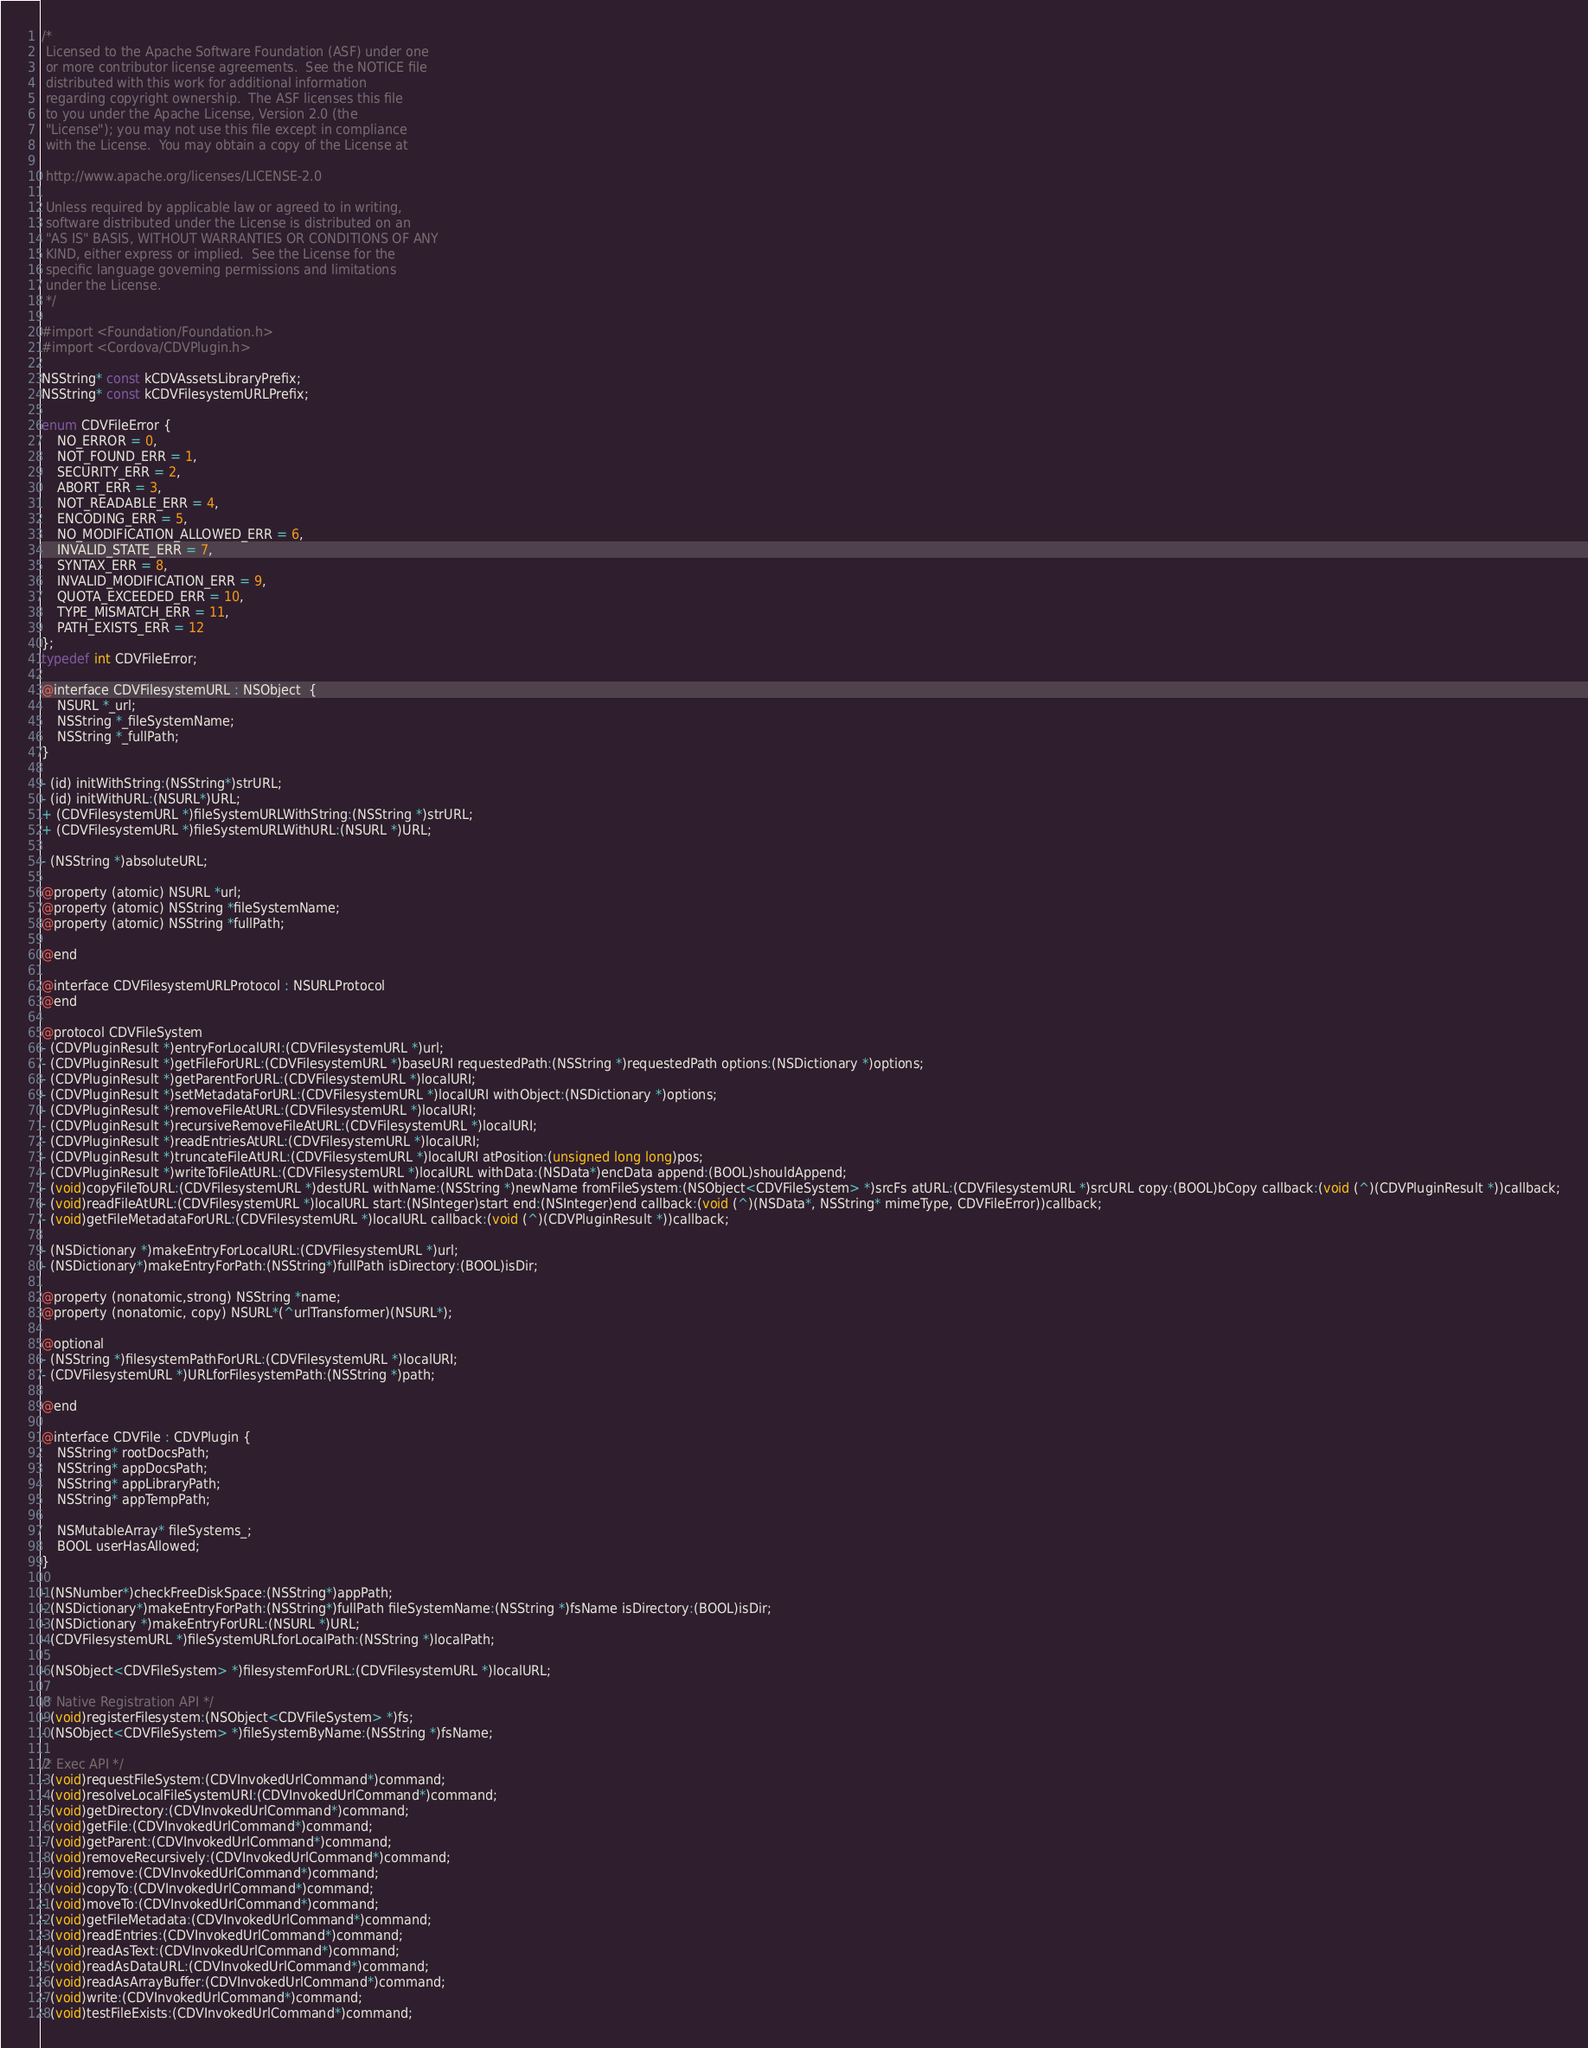Convert code to text. <code><loc_0><loc_0><loc_500><loc_500><_C_>/*
 Licensed to the Apache Software Foundation (ASF) under one
 or more contributor license agreements.  See the NOTICE file
 distributed with this work for additional information
 regarding copyright ownership.  The ASF licenses this file
 to you under the Apache License, Version 2.0 (the
 "License"); you may not use this file except in compliance
 with the License.  You may obtain a copy of the License at

 http://www.apache.org/licenses/LICENSE-2.0

 Unless required by applicable law or agreed to in writing,
 software distributed under the License is distributed on an
 "AS IS" BASIS, WITHOUT WARRANTIES OR CONDITIONS OF ANY
 KIND, either express or implied.  See the License for the
 specific language governing permissions and limitations
 under the License.
 */

#import <Foundation/Foundation.h>
#import <Cordova/CDVPlugin.h>

NSString* const kCDVAssetsLibraryPrefix;
NSString* const kCDVFilesystemURLPrefix;

enum CDVFileError {
    NO_ERROR = 0,
    NOT_FOUND_ERR = 1,
    SECURITY_ERR = 2,
    ABORT_ERR = 3,
    NOT_READABLE_ERR = 4,
    ENCODING_ERR = 5,
    NO_MODIFICATION_ALLOWED_ERR = 6,
    INVALID_STATE_ERR = 7,
    SYNTAX_ERR = 8,
    INVALID_MODIFICATION_ERR = 9,
    QUOTA_EXCEEDED_ERR = 10,
    TYPE_MISMATCH_ERR = 11,
    PATH_EXISTS_ERR = 12
};
typedef int CDVFileError;

@interface CDVFilesystemURL : NSObject  {
    NSURL *_url;
    NSString *_fileSystemName;
    NSString *_fullPath;
}

- (id) initWithString:(NSString*)strURL;
- (id) initWithURL:(NSURL*)URL;
+ (CDVFilesystemURL *)fileSystemURLWithString:(NSString *)strURL;
+ (CDVFilesystemURL *)fileSystemURLWithURL:(NSURL *)URL;

- (NSString *)absoluteURL;

@property (atomic) NSURL *url;
@property (atomic) NSString *fileSystemName;
@property (atomic) NSString *fullPath;

@end

@interface CDVFilesystemURLProtocol : NSURLProtocol
@end

@protocol CDVFileSystem
- (CDVPluginResult *)entryForLocalURI:(CDVFilesystemURL *)url;
- (CDVPluginResult *)getFileForURL:(CDVFilesystemURL *)baseURI requestedPath:(NSString *)requestedPath options:(NSDictionary *)options;
- (CDVPluginResult *)getParentForURL:(CDVFilesystemURL *)localURI;
- (CDVPluginResult *)setMetadataForURL:(CDVFilesystemURL *)localURI withObject:(NSDictionary *)options;
- (CDVPluginResult *)removeFileAtURL:(CDVFilesystemURL *)localURI;
- (CDVPluginResult *)recursiveRemoveFileAtURL:(CDVFilesystemURL *)localURI;
- (CDVPluginResult *)readEntriesAtURL:(CDVFilesystemURL *)localURI;
- (CDVPluginResult *)truncateFileAtURL:(CDVFilesystemURL *)localURI atPosition:(unsigned long long)pos;
- (CDVPluginResult *)writeToFileAtURL:(CDVFilesystemURL *)localURL withData:(NSData*)encData append:(BOOL)shouldAppend;
- (void)copyFileToURL:(CDVFilesystemURL *)destURL withName:(NSString *)newName fromFileSystem:(NSObject<CDVFileSystem> *)srcFs atURL:(CDVFilesystemURL *)srcURL copy:(BOOL)bCopy callback:(void (^)(CDVPluginResult *))callback;
- (void)readFileAtURL:(CDVFilesystemURL *)localURL start:(NSInteger)start end:(NSInteger)end callback:(void (^)(NSData*, NSString* mimeType, CDVFileError))callback;
- (void)getFileMetadataForURL:(CDVFilesystemURL *)localURL callback:(void (^)(CDVPluginResult *))callback;

- (NSDictionary *)makeEntryForLocalURL:(CDVFilesystemURL *)url;
- (NSDictionary*)makeEntryForPath:(NSString*)fullPath isDirectory:(BOOL)isDir;

@property (nonatomic,strong) NSString *name;
@property (nonatomic, copy) NSURL*(^urlTransformer)(NSURL*);

@optional
- (NSString *)filesystemPathForURL:(CDVFilesystemURL *)localURI;
- (CDVFilesystemURL *)URLforFilesystemPath:(NSString *)path;

@end

@interface CDVFile : CDVPlugin {
    NSString* rootDocsPath;
    NSString* appDocsPath;
    NSString* appLibraryPath;
    NSString* appTempPath;

    NSMutableArray* fileSystems_;
    BOOL userHasAllowed;
}

- (NSNumber*)checkFreeDiskSpace:(NSString*)appPath;
- (NSDictionary*)makeEntryForPath:(NSString*)fullPath fileSystemName:(NSString *)fsName isDirectory:(BOOL)isDir;
- (NSDictionary *)makeEntryForURL:(NSURL *)URL;
- (CDVFilesystemURL *)fileSystemURLforLocalPath:(NSString *)localPath;

- (NSObject<CDVFileSystem> *)filesystemForURL:(CDVFilesystemURL *)localURL;

/* Native Registration API */
- (void)registerFilesystem:(NSObject<CDVFileSystem> *)fs;
- (NSObject<CDVFileSystem> *)fileSystemByName:(NSString *)fsName;

/* Exec API */
- (void)requestFileSystem:(CDVInvokedUrlCommand*)command;
- (void)resolveLocalFileSystemURI:(CDVInvokedUrlCommand*)command;
- (void)getDirectory:(CDVInvokedUrlCommand*)command;
- (void)getFile:(CDVInvokedUrlCommand*)command;
- (void)getParent:(CDVInvokedUrlCommand*)command;
- (void)removeRecursively:(CDVInvokedUrlCommand*)command;
- (void)remove:(CDVInvokedUrlCommand*)command;
- (void)copyTo:(CDVInvokedUrlCommand*)command;
- (void)moveTo:(CDVInvokedUrlCommand*)command;
- (void)getFileMetadata:(CDVInvokedUrlCommand*)command;
- (void)readEntries:(CDVInvokedUrlCommand*)command;
- (void)readAsText:(CDVInvokedUrlCommand*)command;
- (void)readAsDataURL:(CDVInvokedUrlCommand*)command;
- (void)readAsArrayBuffer:(CDVInvokedUrlCommand*)command;
- (void)write:(CDVInvokedUrlCommand*)command;
- (void)testFileExists:(CDVInvokedUrlCommand*)command;</code> 